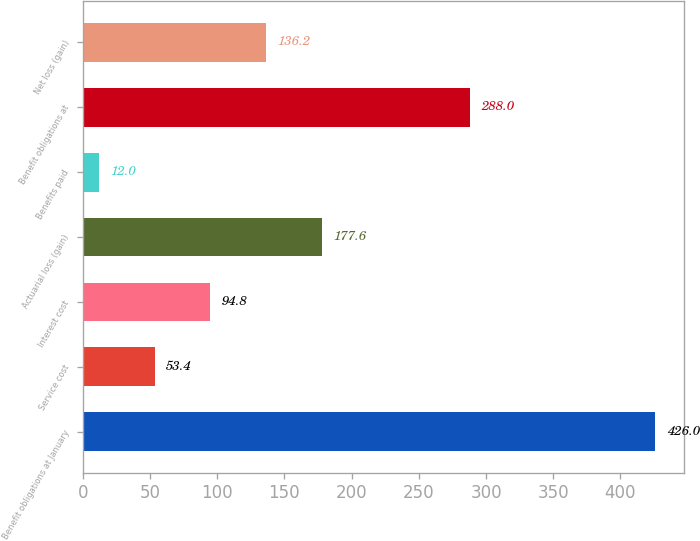Convert chart. <chart><loc_0><loc_0><loc_500><loc_500><bar_chart><fcel>Benefit obligations at January<fcel>Service cost<fcel>Interest cost<fcel>Actuarial loss (gain)<fcel>Benefits paid<fcel>Benefit obligations at<fcel>Net loss (gain)<nl><fcel>426<fcel>53.4<fcel>94.8<fcel>177.6<fcel>12<fcel>288<fcel>136.2<nl></chart> 